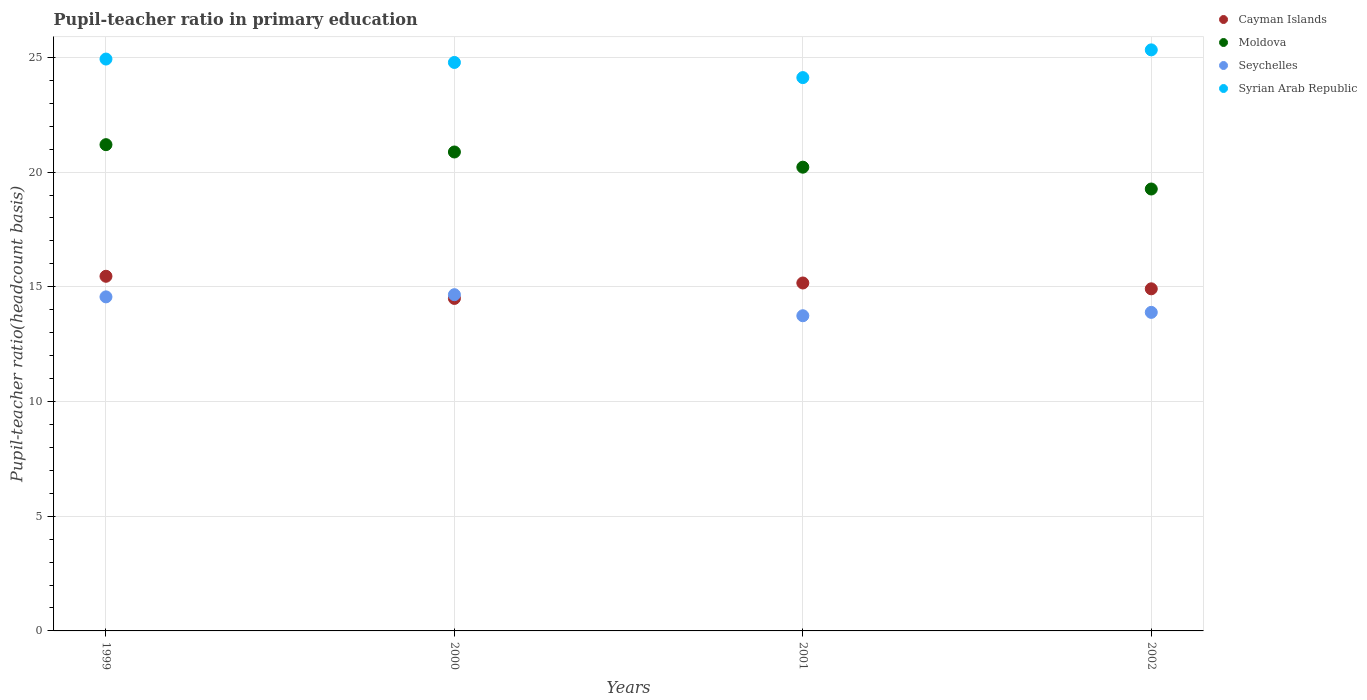What is the pupil-teacher ratio in primary education in Syrian Arab Republic in 2000?
Your answer should be compact. 24.78. Across all years, what is the maximum pupil-teacher ratio in primary education in Syrian Arab Republic?
Ensure brevity in your answer.  25.33. Across all years, what is the minimum pupil-teacher ratio in primary education in Syrian Arab Republic?
Your answer should be compact. 24.12. In which year was the pupil-teacher ratio in primary education in Syrian Arab Republic maximum?
Your answer should be compact. 2002. In which year was the pupil-teacher ratio in primary education in Cayman Islands minimum?
Give a very brief answer. 2000. What is the total pupil-teacher ratio in primary education in Moldova in the graph?
Give a very brief answer. 81.55. What is the difference between the pupil-teacher ratio in primary education in Syrian Arab Republic in 2000 and that in 2001?
Offer a terse response. 0.66. What is the difference between the pupil-teacher ratio in primary education in Seychelles in 2002 and the pupil-teacher ratio in primary education in Moldova in 2001?
Provide a succinct answer. -6.33. What is the average pupil-teacher ratio in primary education in Seychelles per year?
Make the answer very short. 14.21. In the year 1999, what is the difference between the pupil-teacher ratio in primary education in Seychelles and pupil-teacher ratio in primary education in Cayman Islands?
Make the answer very short. -0.9. In how many years, is the pupil-teacher ratio in primary education in Moldova greater than 24?
Offer a terse response. 0. What is the ratio of the pupil-teacher ratio in primary education in Seychelles in 2000 to that in 2002?
Your response must be concise. 1.06. Is the difference between the pupil-teacher ratio in primary education in Seychelles in 1999 and 2002 greater than the difference between the pupil-teacher ratio in primary education in Cayman Islands in 1999 and 2002?
Provide a succinct answer. Yes. What is the difference between the highest and the second highest pupil-teacher ratio in primary education in Seychelles?
Make the answer very short. 0.09. What is the difference between the highest and the lowest pupil-teacher ratio in primary education in Seychelles?
Make the answer very short. 0.92. Is the sum of the pupil-teacher ratio in primary education in Moldova in 1999 and 2000 greater than the maximum pupil-teacher ratio in primary education in Cayman Islands across all years?
Give a very brief answer. Yes. Is it the case that in every year, the sum of the pupil-teacher ratio in primary education in Moldova and pupil-teacher ratio in primary education in Seychelles  is greater than the pupil-teacher ratio in primary education in Cayman Islands?
Give a very brief answer. Yes. Is the pupil-teacher ratio in primary education in Syrian Arab Republic strictly greater than the pupil-teacher ratio in primary education in Seychelles over the years?
Your answer should be compact. Yes. Is the pupil-teacher ratio in primary education in Cayman Islands strictly less than the pupil-teacher ratio in primary education in Moldova over the years?
Ensure brevity in your answer.  Yes. How many dotlines are there?
Give a very brief answer. 4. How many years are there in the graph?
Make the answer very short. 4. Are the values on the major ticks of Y-axis written in scientific E-notation?
Your answer should be very brief. No. Does the graph contain any zero values?
Make the answer very short. No. Where does the legend appear in the graph?
Your answer should be very brief. Top right. How many legend labels are there?
Keep it short and to the point. 4. What is the title of the graph?
Make the answer very short. Pupil-teacher ratio in primary education. What is the label or title of the X-axis?
Provide a short and direct response. Years. What is the label or title of the Y-axis?
Your answer should be very brief. Pupil-teacher ratio(headcount basis). What is the Pupil-teacher ratio(headcount basis) of Cayman Islands in 1999?
Your answer should be very brief. 15.46. What is the Pupil-teacher ratio(headcount basis) of Moldova in 1999?
Ensure brevity in your answer.  21.2. What is the Pupil-teacher ratio(headcount basis) in Seychelles in 1999?
Offer a terse response. 14.56. What is the Pupil-teacher ratio(headcount basis) in Syrian Arab Republic in 1999?
Ensure brevity in your answer.  24.93. What is the Pupil-teacher ratio(headcount basis) in Cayman Islands in 2000?
Give a very brief answer. 14.49. What is the Pupil-teacher ratio(headcount basis) of Moldova in 2000?
Offer a terse response. 20.88. What is the Pupil-teacher ratio(headcount basis) in Seychelles in 2000?
Provide a short and direct response. 14.66. What is the Pupil-teacher ratio(headcount basis) in Syrian Arab Republic in 2000?
Offer a very short reply. 24.78. What is the Pupil-teacher ratio(headcount basis) in Cayman Islands in 2001?
Give a very brief answer. 15.17. What is the Pupil-teacher ratio(headcount basis) of Moldova in 2001?
Your response must be concise. 20.21. What is the Pupil-teacher ratio(headcount basis) of Seychelles in 2001?
Offer a very short reply. 13.74. What is the Pupil-teacher ratio(headcount basis) in Syrian Arab Republic in 2001?
Provide a short and direct response. 24.12. What is the Pupil-teacher ratio(headcount basis) of Cayman Islands in 2002?
Provide a succinct answer. 14.91. What is the Pupil-teacher ratio(headcount basis) in Moldova in 2002?
Provide a succinct answer. 19.26. What is the Pupil-teacher ratio(headcount basis) of Seychelles in 2002?
Make the answer very short. 13.89. What is the Pupil-teacher ratio(headcount basis) of Syrian Arab Republic in 2002?
Provide a short and direct response. 25.33. Across all years, what is the maximum Pupil-teacher ratio(headcount basis) in Cayman Islands?
Make the answer very short. 15.46. Across all years, what is the maximum Pupil-teacher ratio(headcount basis) of Moldova?
Provide a short and direct response. 21.2. Across all years, what is the maximum Pupil-teacher ratio(headcount basis) in Seychelles?
Keep it short and to the point. 14.66. Across all years, what is the maximum Pupil-teacher ratio(headcount basis) in Syrian Arab Republic?
Keep it short and to the point. 25.33. Across all years, what is the minimum Pupil-teacher ratio(headcount basis) in Cayman Islands?
Keep it short and to the point. 14.49. Across all years, what is the minimum Pupil-teacher ratio(headcount basis) of Moldova?
Offer a very short reply. 19.26. Across all years, what is the minimum Pupil-teacher ratio(headcount basis) of Seychelles?
Your answer should be very brief. 13.74. Across all years, what is the minimum Pupil-teacher ratio(headcount basis) of Syrian Arab Republic?
Offer a terse response. 24.12. What is the total Pupil-teacher ratio(headcount basis) of Cayman Islands in the graph?
Offer a terse response. 60.03. What is the total Pupil-teacher ratio(headcount basis) in Moldova in the graph?
Provide a short and direct response. 81.55. What is the total Pupil-teacher ratio(headcount basis) in Seychelles in the graph?
Ensure brevity in your answer.  56.84. What is the total Pupil-teacher ratio(headcount basis) in Syrian Arab Republic in the graph?
Your answer should be very brief. 99.16. What is the difference between the Pupil-teacher ratio(headcount basis) in Cayman Islands in 1999 and that in 2000?
Your answer should be compact. 0.97. What is the difference between the Pupil-teacher ratio(headcount basis) of Moldova in 1999 and that in 2000?
Your answer should be compact. 0.32. What is the difference between the Pupil-teacher ratio(headcount basis) in Seychelles in 1999 and that in 2000?
Ensure brevity in your answer.  -0.09. What is the difference between the Pupil-teacher ratio(headcount basis) of Syrian Arab Republic in 1999 and that in 2000?
Offer a terse response. 0.15. What is the difference between the Pupil-teacher ratio(headcount basis) in Cayman Islands in 1999 and that in 2001?
Offer a terse response. 0.29. What is the difference between the Pupil-teacher ratio(headcount basis) of Moldova in 1999 and that in 2001?
Offer a very short reply. 0.98. What is the difference between the Pupil-teacher ratio(headcount basis) in Seychelles in 1999 and that in 2001?
Give a very brief answer. 0.82. What is the difference between the Pupil-teacher ratio(headcount basis) of Syrian Arab Republic in 1999 and that in 2001?
Offer a terse response. 0.81. What is the difference between the Pupil-teacher ratio(headcount basis) of Cayman Islands in 1999 and that in 2002?
Your answer should be very brief. 0.55. What is the difference between the Pupil-teacher ratio(headcount basis) of Moldova in 1999 and that in 2002?
Provide a succinct answer. 1.93. What is the difference between the Pupil-teacher ratio(headcount basis) of Seychelles in 1999 and that in 2002?
Keep it short and to the point. 0.68. What is the difference between the Pupil-teacher ratio(headcount basis) of Syrian Arab Republic in 1999 and that in 2002?
Give a very brief answer. -0.4. What is the difference between the Pupil-teacher ratio(headcount basis) in Cayman Islands in 2000 and that in 2001?
Your response must be concise. -0.67. What is the difference between the Pupil-teacher ratio(headcount basis) of Moldova in 2000 and that in 2001?
Your answer should be compact. 0.66. What is the difference between the Pupil-teacher ratio(headcount basis) in Seychelles in 2000 and that in 2001?
Provide a short and direct response. 0.92. What is the difference between the Pupil-teacher ratio(headcount basis) of Syrian Arab Republic in 2000 and that in 2001?
Give a very brief answer. 0.66. What is the difference between the Pupil-teacher ratio(headcount basis) in Cayman Islands in 2000 and that in 2002?
Offer a terse response. -0.42. What is the difference between the Pupil-teacher ratio(headcount basis) of Moldova in 2000 and that in 2002?
Keep it short and to the point. 1.61. What is the difference between the Pupil-teacher ratio(headcount basis) of Seychelles in 2000 and that in 2002?
Offer a terse response. 0.77. What is the difference between the Pupil-teacher ratio(headcount basis) of Syrian Arab Republic in 2000 and that in 2002?
Provide a short and direct response. -0.55. What is the difference between the Pupil-teacher ratio(headcount basis) in Cayman Islands in 2001 and that in 2002?
Offer a terse response. 0.25. What is the difference between the Pupil-teacher ratio(headcount basis) in Moldova in 2001 and that in 2002?
Ensure brevity in your answer.  0.95. What is the difference between the Pupil-teacher ratio(headcount basis) in Seychelles in 2001 and that in 2002?
Provide a short and direct response. -0.15. What is the difference between the Pupil-teacher ratio(headcount basis) of Syrian Arab Republic in 2001 and that in 2002?
Keep it short and to the point. -1.21. What is the difference between the Pupil-teacher ratio(headcount basis) of Cayman Islands in 1999 and the Pupil-teacher ratio(headcount basis) of Moldova in 2000?
Ensure brevity in your answer.  -5.42. What is the difference between the Pupil-teacher ratio(headcount basis) of Cayman Islands in 1999 and the Pupil-teacher ratio(headcount basis) of Seychelles in 2000?
Ensure brevity in your answer.  0.8. What is the difference between the Pupil-teacher ratio(headcount basis) of Cayman Islands in 1999 and the Pupil-teacher ratio(headcount basis) of Syrian Arab Republic in 2000?
Offer a terse response. -9.32. What is the difference between the Pupil-teacher ratio(headcount basis) of Moldova in 1999 and the Pupil-teacher ratio(headcount basis) of Seychelles in 2000?
Ensure brevity in your answer.  6.54. What is the difference between the Pupil-teacher ratio(headcount basis) in Moldova in 1999 and the Pupil-teacher ratio(headcount basis) in Syrian Arab Republic in 2000?
Keep it short and to the point. -3.58. What is the difference between the Pupil-teacher ratio(headcount basis) of Seychelles in 1999 and the Pupil-teacher ratio(headcount basis) of Syrian Arab Republic in 2000?
Make the answer very short. -10.22. What is the difference between the Pupil-teacher ratio(headcount basis) of Cayman Islands in 1999 and the Pupil-teacher ratio(headcount basis) of Moldova in 2001?
Your response must be concise. -4.76. What is the difference between the Pupil-teacher ratio(headcount basis) in Cayman Islands in 1999 and the Pupil-teacher ratio(headcount basis) in Seychelles in 2001?
Your answer should be compact. 1.72. What is the difference between the Pupil-teacher ratio(headcount basis) in Cayman Islands in 1999 and the Pupil-teacher ratio(headcount basis) in Syrian Arab Republic in 2001?
Offer a terse response. -8.66. What is the difference between the Pupil-teacher ratio(headcount basis) in Moldova in 1999 and the Pupil-teacher ratio(headcount basis) in Seychelles in 2001?
Offer a terse response. 7.46. What is the difference between the Pupil-teacher ratio(headcount basis) of Moldova in 1999 and the Pupil-teacher ratio(headcount basis) of Syrian Arab Republic in 2001?
Offer a very short reply. -2.92. What is the difference between the Pupil-teacher ratio(headcount basis) of Seychelles in 1999 and the Pupil-teacher ratio(headcount basis) of Syrian Arab Republic in 2001?
Offer a terse response. -9.56. What is the difference between the Pupil-teacher ratio(headcount basis) in Cayman Islands in 1999 and the Pupil-teacher ratio(headcount basis) in Moldova in 2002?
Your answer should be compact. -3.8. What is the difference between the Pupil-teacher ratio(headcount basis) in Cayman Islands in 1999 and the Pupil-teacher ratio(headcount basis) in Seychelles in 2002?
Offer a very short reply. 1.57. What is the difference between the Pupil-teacher ratio(headcount basis) in Cayman Islands in 1999 and the Pupil-teacher ratio(headcount basis) in Syrian Arab Republic in 2002?
Offer a terse response. -9.87. What is the difference between the Pupil-teacher ratio(headcount basis) of Moldova in 1999 and the Pupil-teacher ratio(headcount basis) of Seychelles in 2002?
Your response must be concise. 7.31. What is the difference between the Pupil-teacher ratio(headcount basis) in Moldova in 1999 and the Pupil-teacher ratio(headcount basis) in Syrian Arab Republic in 2002?
Give a very brief answer. -4.13. What is the difference between the Pupil-teacher ratio(headcount basis) in Seychelles in 1999 and the Pupil-teacher ratio(headcount basis) in Syrian Arab Republic in 2002?
Offer a terse response. -10.77. What is the difference between the Pupil-teacher ratio(headcount basis) of Cayman Islands in 2000 and the Pupil-teacher ratio(headcount basis) of Moldova in 2001?
Make the answer very short. -5.72. What is the difference between the Pupil-teacher ratio(headcount basis) of Cayman Islands in 2000 and the Pupil-teacher ratio(headcount basis) of Seychelles in 2001?
Your answer should be very brief. 0.75. What is the difference between the Pupil-teacher ratio(headcount basis) in Cayman Islands in 2000 and the Pupil-teacher ratio(headcount basis) in Syrian Arab Republic in 2001?
Offer a very short reply. -9.63. What is the difference between the Pupil-teacher ratio(headcount basis) of Moldova in 2000 and the Pupil-teacher ratio(headcount basis) of Seychelles in 2001?
Provide a short and direct response. 7.14. What is the difference between the Pupil-teacher ratio(headcount basis) in Moldova in 2000 and the Pupil-teacher ratio(headcount basis) in Syrian Arab Republic in 2001?
Offer a terse response. -3.24. What is the difference between the Pupil-teacher ratio(headcount basis) in Seychelles in 2000 and the Pupil-teacher ratio(headcount basis) in Syrian Arab Republic in 2001?
Provide a short and direct response. -9.46. What is the difference between the Pupil-teacher ratio(headcount basis) of Cayman Islands in 2000 and the Pupil-teacher ratio(headcount basis) of Moldova in 2002?
Your answer should be compact. -4.77. What is the difference between the Pupil-teacher ratio(headcount basis) in Cayman Islands in 2000 and the Pupil-teacher ratio(headcount basis) in Seychelles in 2002?
Your response must be concise. 0.61. What is the difference between the Pupil-teacher ratio(headcount basis) in Cayman Islands in 2000 and the Pupil-teacher ratio(headcount basis) in Syrian Arab Republic in 2002?
Give a very brief answer. -10.83. What is the difference between the Pupil-teacher ratio(headcount basis) of Moldova in 2000 and the Pupil-teacher ratio(headcount basis) of Seychelles in 2002?
Make the answer very short. 6.99. What is the difference between the Pupil-teacher ratio(headcount basis) in Moldova in 2000 and the Pupil-teacher ratio(headcount basis) in Syrian Arab Republic in 2002?
Your response must be concise. -4.45. What is the difference between the Pupil-teacher ratio(headcount basis) in Seychelles in 2000 and the Pupil-teacher ratio(headcount basis) in Syrian Arab Republic in 2002?
Provide a short and direct response. -10.67. What is the difference between the Pupil-teacher ratio(headcount basis) in Cayman Islands in 2001 and the Pupil-teacher ratio(headcount basis) in Moldova in 2002?
Ensure brevity in your answer.  -4.1. What is the difference between the Pupil-teacher ratio(headcount basis) of Cayman Islands in 2001 and the Pupil-teacher ratio(headcount basis) of Seychelles in 2002?
Make the answer very short. 1.28. What is the difference between the Pupil-teacher ratio(headcount basis) of Cayman Islands in 2001 and the Pupil-teacher ratio(headcount basis) of Syrian Arab Republic in 2002?
Your response must be concise. -10.16. What is the difference between the Pupil-teacher ratio(headcount basis) in Moldova in 2001 and the Pupil-teacher ratio(headcount basis) in Seychelles in 2002?
Your answer should be compact. 6.33. What is the difference between the Pupil-teacher ratio(headcount basis) in Moldova in 2001 and the Pupil-teacher ratio(headcount basis) in Syrian Arab Republic in 2002?
Provide a short and direct response. -5.11. What is the difference between the Pupil-teacher ratio(headcount basis) in Seychelles in 2001 and the Pupil-teacher ratio(headcount basis) in Syrian Arab Republic in 2002?
Provide a short and direct response. -11.59. What is the average Pupil-teacher ratio(headcount basis) in Cayman Islands per year?
Ensure brevity in your answer.  15.01. What is the average Pupil-teacher ratio(headcount basis) of Moldova per year?
Ensure brevity in your answer.  20.39. What is the average Pupil-teacher ratio(headcount basis) in Seychelles per year?
Provide a succinct answer. 14.21. What is the average Pupil-teacher ratio(headcount basis) of Syrian Arab Republic per year?
Your answer should be compact. 24.79. In the year 1999, what is the difference between the Pupil-teacher ratio(headcount basis) in Cayman Islands and Pupil-teacher ratio(headcount basis) in Moldova?
Offer a terse response. -5.74. In the year 1999, what is the difference between the Pupil-teacher ratio(headcount basis) in Cayman Islands and Pupil-teacher ratio(headcount basis) in Seychelles?
Give a very brief answer. 0.9. In the year 1999, what is the difference between the Pupil-teacher ratio(headcount basis) in Cayman Islands and Pupil-teacher ratio(headcount basis) in Syrian Arab Republic?
Your response must be concise. -9.47. In the year 1999, what is the difference between the Pupil-teacher ratio(headcount basis) in Moldova and Pupil-teacher ratio(headcount basis) in Seychelles?
Ensure brevity in your answer.  6.63. In the year 1999, what is the difference between the Pupil-teacher ratio(headcount basis) in Moldova and Pupil-teacher ratio(headcount basis) in Syrian Arab Republic?
Your response must be concise. -3.73. In the year 1999, what is the difference between the Pupil-teacher ratio(headcount basis) in Seychelles and Pupil-teacher ratio(headcount basis) in Syrian Arab Republic?
Your answer should be compact. -10.37. In the year 2000, what is the difference between the Pupil-teacher ratio(headcount basis) in Cayman Islands and Pupil-teacher ratio(headcount basis) in Moldova?
Your answer should be compact. -6.38. In the year 2000, what is the difference between the Pupil-teacher ratio(headcount basis) of Cayman Islands and Pupil-teacher ratio(headcount basis) of Seychelles?
Your answer should be very brief. -0.16. In the year 2000, what is the difference between the Pupil-teacher ratio(headcount basis) in Cayman Islands and Pupil-teacher ratio(headcount basis) in Syrian Arab Republic?
Keep it short and to the point. -10.29. In the year 2000, what is the difference between the Pupil-teacher ratio(headcount basis) of Moldova and Pupil-teacher ratio(headcount basis) of Seychelles?
Your response must be concise. 6.22. In the year 2000, what is the difference between the Pupil-teacher ratio(headcount basis) in Moldova and Pupil-teacher ratio(headcount basis) in Syrian Arab Republic?
Your response must be concise. -3.9. In the year 2000, what is the difference between the Pupil-teacher ratio(headcount basis) in Seychelles and Pupil-teacher ratio(headcount basis) in Syrian Arab Republic?
Your answer should be very brief. -10.12. In the year 2001, what is the difference between the Pupil-teacher ratio(headcount basis) in Cayman Islands and Pupil-teacher ratio(headcount basis) in Moldova?
Provide a short and direct response. -5.05. In the year 2001, what is the difference between the Pupil-teacher ratio(headcount basis) in Cayman Islands and Pupil-teacher ratio(headcount basis) in Seychelles?
Give a very brief answer. 1.43. In the year 2001, what is the difference between the Pupil-teacher ratio(headcount basis) in Cayman Islands and Pupil-teacher ratio(headcount basis) in Syrian Arab Republic?
Your response must be concise. -8.95. In the year 2001, what is the difference between the Pupil-teacher ratio(headcount basis) in Moldova and Pupil-teacher ratio(headcount basis) in Seychelles?
Provide a succinct answer. 6.48. In the year 2001, what is the difference between the Pupil-teacher ratio(headcount basis) in Moldova and Pupil-teacher ratio(headcount basis) in Syrian Arab Republic?
Provide a succinct answer. -3.9. In the year 2001, what is the difference between the Pupil-teacher ratio(headcount basis) of Seychelles and Pupil-teacher ratio(headcount basis) of Syrian Arab Republic?
Provide a short and direct response. -10.38. In the year 2002, what is the difference between the Pupil-teacher ratio(headcount basis) in Cayman Islands and Pupil-teacher ratio(headcount basis) in Moldova?
Make the answer very short. -4.35. In the year 2002, what is the difference between the Pupil-teacher ratio(headcount basis) in Cayman Islands and Pupil-teacher ratio(headcount basis) in Seychelles?
Offer a terse response. 1.03. In the year 2002, what is the difference between the Pupil-teacher ratio(headcount basis) of Cayman Islands and Pupil-teacher ratio(headcount basis) of Syrian Arab Republic?
Offer a very short reply. -10.42. In the year 2002, what is the difference between the Pupil-teacher ratio(headcount basis) of Moldova and Pupil-teacher ratio(headcount basis) of Seychelles?
Your response must be concise. 5.38. In the year 2002, what is the difference between the Pupil-teacher ratio(headcount basis) in Moldova and Pupil-teacher ratio(headcount basis) in Syrian Arab Republic?
Provide a short and direct response. -6.07. In the year 2002, what is the difference between the Pupil-teacher ratio(headcount basis) of Seychelles and Pupil-teacher ratio(headcount basis) of Syrian Arab Republic?
Give a very brief answer. -11.44. What is the ratio of the Pupil-teacher ratio(headcount basis) of Cayman Islands in 1999 to that in 2000?
Provide a succinct answer. 1.07. What is the ratio of the Pupil-teacher ratio(headcount basis) of Moldova in 1999 to that in 2000?
Offer a very short reply. 1.02. What is the ratio of the Pupil-teacher ratio(headcount basis) in Seychelles in 1999 to that in 2000?
Your answer should be compact. 0.99. What is the ratio of the Pupil-teacher ratio(headcount basis) in Syrian Arab Republic in 1999 to that in 2000?
Your answer should be very brief. 1.01. What is the ratio of the Pupil-teacher ratio(headcount basis) of Cayman Islands in 1999 to that in 2001?
Make the answer very short. 1.02. What is the ratio of the Pupil-teacher ratio(headcount basis) in Moldova in 1999 to that in 2001?
Offer a very short reply. 1.05. What is the ratio of the Pupil-teacher ratio(headcount basis) in Seychelles in 1999 to that in 2001?
Keep it short and to the point. 1.06. What is the ratio of the Pupil-teacher ratio(headcount basis) of Syrian Arab Republic in 1999 to that in 2001?
Your response must be concise. 1.03. What is the ratio of the Pupil-teacher ratio(headcount basis) of Cayman Islands in 1999 to that in 2002?
Offer a terse response. 1.04. What is the ratio of the Pupil-teacher ratio(headcount basis) in Moldova in 1999 to that in 2002?
Give a very brief answer. 1.1. What is the ratio of the Pupil-teacher ratio(headcount basis) of Seychelles in 1999 to that in 2002?
Make the answer very short. 1.05. What is the ratio of the Pupil-teacher ratio(headcount basis) in Syrian Arab Republic in 1999 to that in 2002?
Offer a very short reply. 0.98. What is the ratio of the Pupil-teacher ratio(headcount basis) of Cayman Islands in 2000 to that in 2001?
Make the answer very short. 0.96. What is the ratio of the Pupil-teacher ratio(headcount basis) in Moldova in 2000 to that in 2001?
Your answer should be compact. 1.03. What is the ratio of the Pupil-teacher ratio(headcount basis) in Seychelles in 2000 to that in 2001?
Offer a very short reply. 1.07. What is the ratio of the Pupil-teacher ratio(headcount basis) of Syrian Arab Republic in 2000 to that in 2001?
Your answer should be very brief. 1.03. What is the ratio of the Pupil-teacher ratio(headcount basis) in Cayman Islands in 2000 to that in 2002?
Offer a terse response. 0.97. What is the ratio of the Pupil-teacher ratio(headcount basis) of Moldova in 2000 to that in 2002?
Your response must be concise. 1.08. What is the ratio of the Pupil-teacher ratio(headcount basis) of Seychelles in 2000 to that in 2002?
Your answer should be compact. 1.06. What is the ratio of the Pupil-teacher ratio(headcount basis) in Syrian Arab Republic in 2000 to that in 2002?
Your answer should be compact. 0.98. What is the ratio of the Pupil-teacher ratio(headcount basis) in Cayman Islands in 2001 to that in 2002?
Give a very brief answer. 1.02. What is the ratio of the Pupil-teacher ratio(headcount basis) of Moldova in 2001 to that in 2002?
Your response must be concise. 1.05. What is the ratio of the Pupil-teacher ratio(headcount basis) in Syrian Arab Republic in 2001 to that in 2002?
Ensure brevity in your answer.  0.95. What is the difference between the highest and the second highest Pupil-teacher ratio(headcount basis) of Cayman Islands?
Give a very brief answer. 0.29. What is the difference between the highest and the second highest Pupil-teacher ratio(headcount basis) in Moldova?
Your response must be concise. 0.32. What is the difference between the highest and the second highest Pupil-teacher ratio(headcount basis) in Seychelles?
Ensure brevity in your answer.  0.09. What is the difference between the highest and the second highest Pupil-teacher ratio(headcount basis) in Syrian Arab Republic?
Offer a terse response. 0.4. What is the difference between the highest and the lowest Pupil-teacher ratio(headcount basis) in Cayman Islands?
Give a very brief answer. 0.97. What is the difference between the highest and the lowest Pupil-teacher ratio(headcount basis) in Moldova?
Your response must be concise. 1.93. What is the difference between the highest and the lowest Pupil-teacher ratio(headcount basis) of Seychelles?
Your response must be concise. 0.92. What is the difference between the highest and the lowest Pupil-teacher ratio(headcount basis) in Syrian Arab Republic?
Your response must be concise. 1.21. 